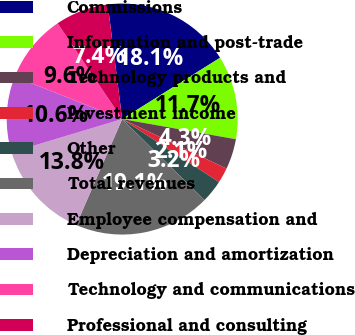Convert chart to OTSL. <chart><loc_0><loc_0><loc_500><loc_500><pie_chart><fcel>Commissions<fcel>Information and post-trade<fcel>Technology products and<fcel>Investment income<fcel>Other<fcel>Total revenues<fcel>Employee compensation and<fcel>Depreciation and amortization<fcel>Technology and communications<fcel>Professional and consulting<nl><fcel>18.09%<fcel>11.7%<fcel>4.26%<fcel>2.13%<fcel>3.19%<fcel>19.15%<fcel>13.83%<fcel>10.64%<fcel>9.57%<fcel>7.45%<nl></chart> 